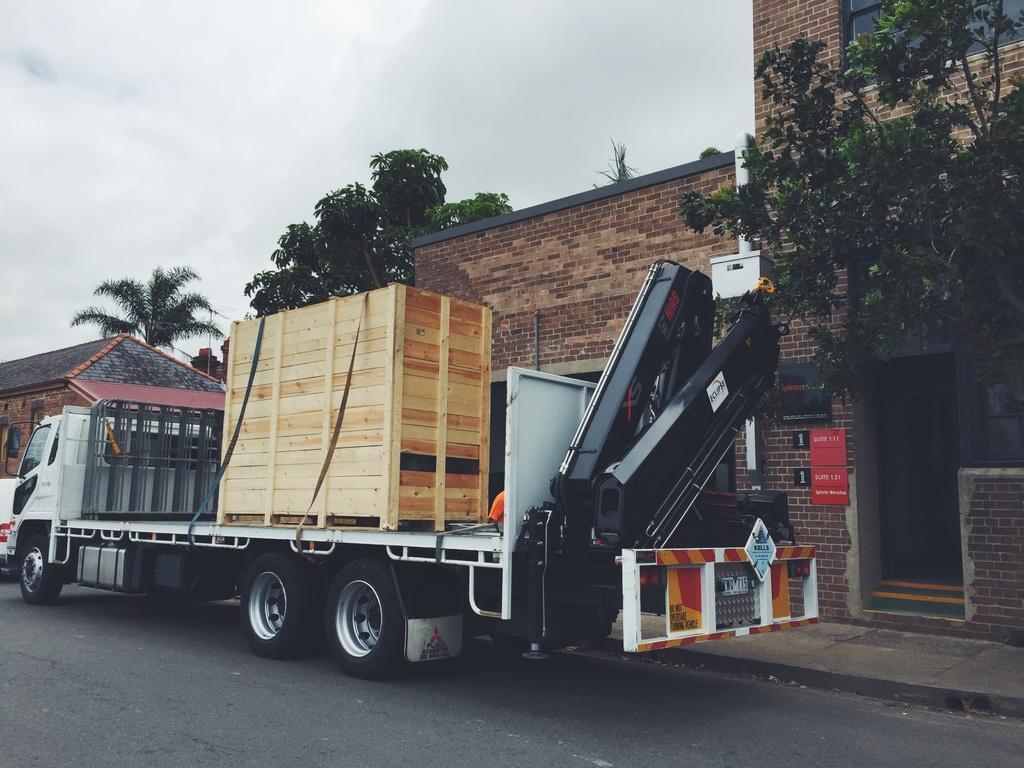How would you summarize this image in a sentence or two? In this image we can see vehicle in which the wooden objects are placed. And back side we can see some board in which text is written. And behind vehicle we can see many buildings and trees. And clouds in the sky. 